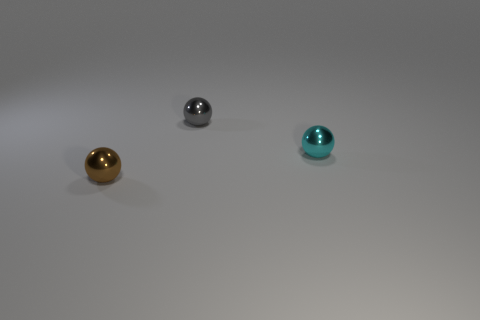Add 2 small cyan metallic spheres. How many objects exist? 5 Subtract all small brown objects. Subtract all small gray cubes. How many objects are left? 2 Add 2 tiny gray things. How many tiny gray things are left? 3 Add 3 metallic things. How many metallic things exist? 6 Subtract 0 blue cubes. How many objects are left? 3 